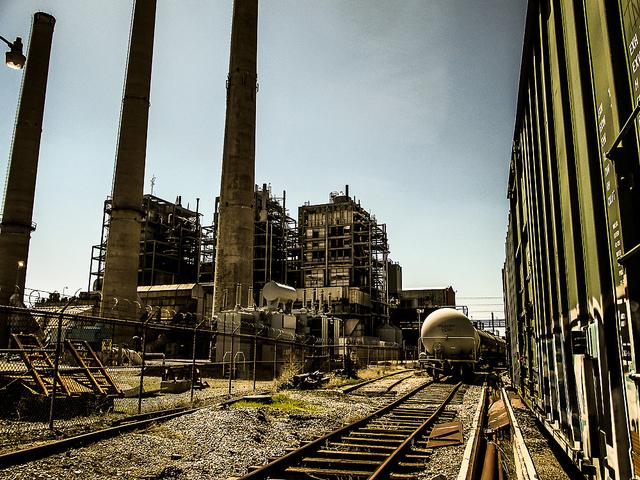Is it raining?
Concise answer only. No. What is on the track?
Write a very short answer. Train. Is it sunny?
Concise answer only. Yes. 